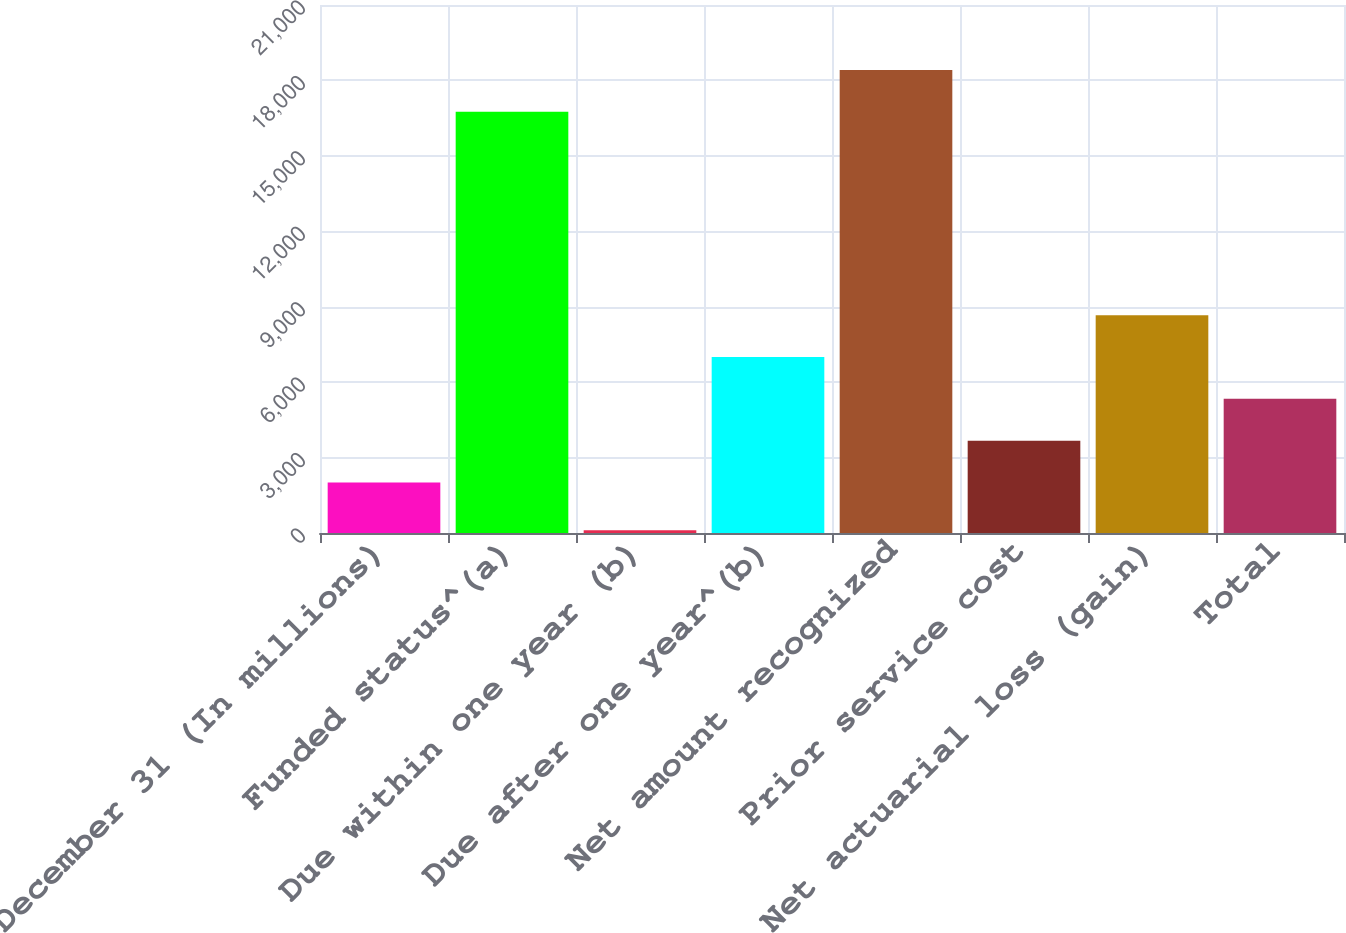Convert chart. <chart><loc_0><loc_0><loc_500><loc_500><bar_chart><fcel>December 31 (In millions)<fcel>Funded status^(a)<fcel>Due within one year (b)<fcel>Due after one year^(b)<fcel>Net amount recognized<fcel>Prior service cost<fcel>Net actuarial loss (gain)<fcel>Total<nl><fcel>2007<fcel>16753<fcel>111<fcel>6999.6<fcel>18417.2<fcel>3671.2<fcel>8663.8<fcel>5335.4<nl></chart> 